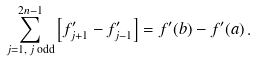<formula> <loc_0><loc_0><loc_500><loc_500>\sum _ { j = 1 , \, j \text { odd} } ^ { 2 n - 1 } \left [ f _ { j + 1 } ^ { \prime } - f _ { j - 1 } ^ { \prime } \right ] = f ^ { \prime } ( b ) - f ^ { \prime } ( a ) \, .</formula> 